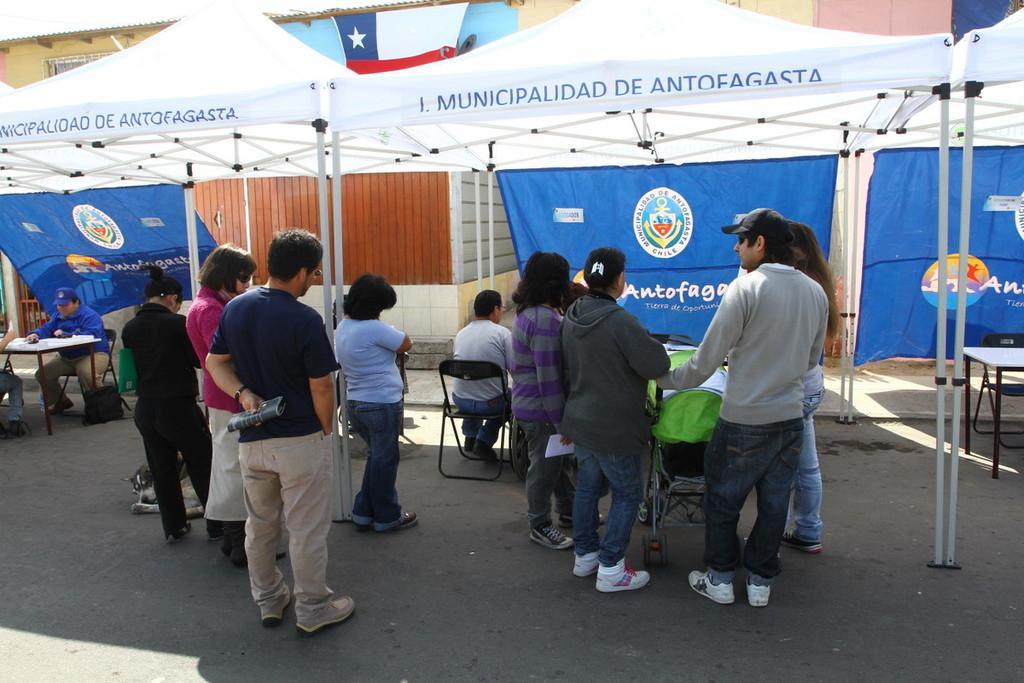How would you summarize this image in a sentence or two? There are groups of people standing and few people sitting. This looks like a stroller. I think these are the canopy tents. These are the banner hanging. This looks like a building. I can see the tables. This is a bag, which is placed on the floor. I can see a dog sitting. 